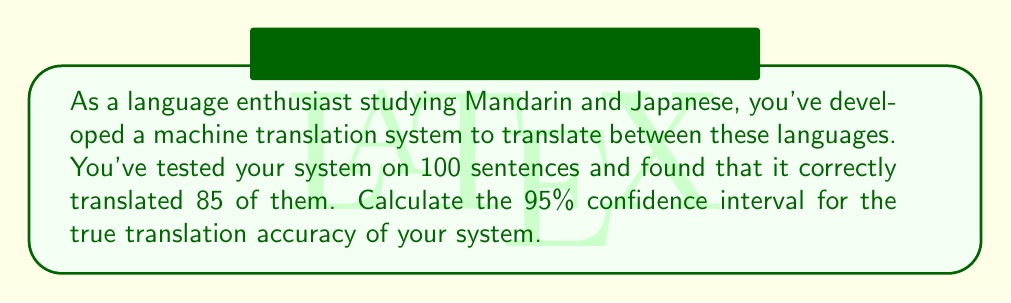Show me your answer to this math problem. Let's approach this step-by-step:

1) We're dealing with a proportion here. The point estimate of the proportion (p̂) is:
   $$\hat{p} = \frac{85}{100} = 0.85$$

2) The sample size (n) is 100.

3) For a 95% confidence interval, we use a z-score of 1.96.

4) The formula for the confidence interval of a proportion is:
   $$\hat{p} \pm z\sqrt{\frac{\hat{p}(1-\hat{p})}{n}}$$

5) Let's calculate the standard error:
   $$SE = \sqrt{\frac{\hat{p}(1-\hat{p})}{n}} = \sqrt{\frac{0.85(1-0.85)}{100}} = \sqrt{\frac{0.1275}{100}} = 0.0357$$

6) Now, let's calculate the margin of error:
   $$ME = 1.96 \times 0.0357 = 0.0700$$

7) Finally, we can calculate the confidence interval:
   Lower bound: $0.85 - 0.0700 = 0.7800$
   Upper bound: $0.85 + 0.0700 = 0.9200$

Therefore, we are 95% confident that the true translation accuracy of the system is between 78.00% and 92.00%.
Answer: (0.7800, 0.9200) 